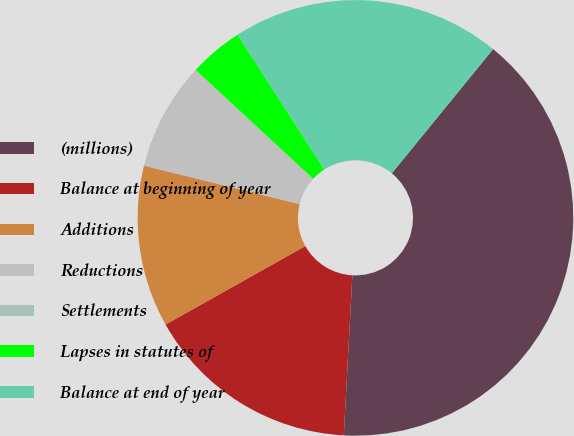<chart> <loc_0><loc_0><loc_500><loc_500><pie_chart><fcel>(millions)<fcel>Balance at beginning of year<fcel>Additions<fcel>Reductions<fcel>Settlements<fcel>Lapses in statutes of<fcel>Balance at end of year<nl><fcel>39.96%<fcel>16.0%<fcel>12.0%<fcel>8.01%<fcel>0.02%<fcel>4.01%<fcel>19.99%<nl></chart> 